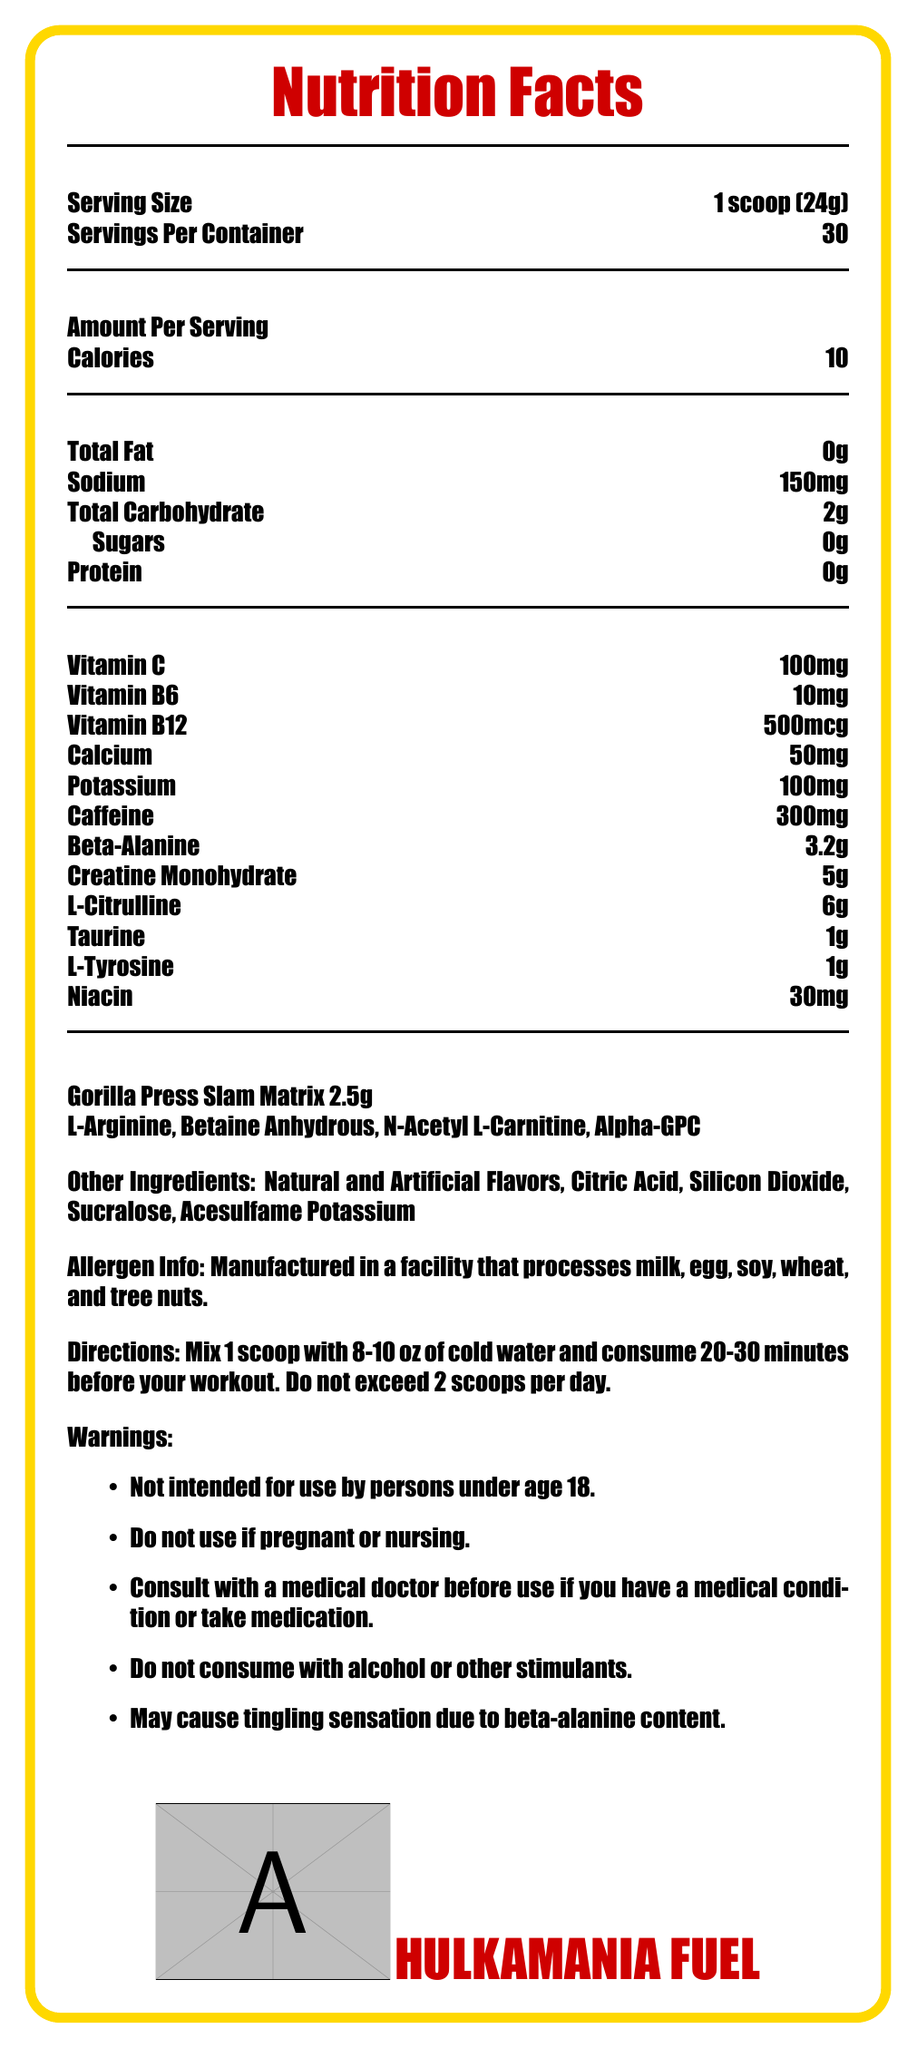What is the serving size of Hulkamania Fuel? The serving size is explicitly listed as 1 scoop (24g) in the document.
Answer: 1 scoop (24g) How many servings are there per container? The document states that there are 30 servings per container.
Answer: 30 How many calories are in one serving of Hulkamania Fuel? The document indicates that there are 10 calories per serving.
Answer: 10 How much caffeine is in each serving? The amount of caffeine per serving is specified as 300mg.
Answer: 300mg Name two vitamins found in Hulkamania Fuel and their amounts. Vitamin C and Vitamin B12 amounts are clearly listed in the document.
Answer: Vitamin C: 100mg, Vitamin B12: 500mcg What is the total weight of the proprietary blend "Gorilla Press Slam Matrix"? The document mentions that the total weight of the Gorilla Press Slam Matrix blend is 2.5g.
Answer: 2.5g Which of the following ingredients is not part of the "Gorilla Press Slam Matrix"? A. L-Arginine B. Betaine Anhydrous C. Alpha-GPC D. Silicon Dioxide Silicon Dioxide is listed as one of the other ingredients, not part of the proprietary blend.
Answer: D. Silicon Dioxide Which ingredient could cause a tingling sensation? A. L-Arginine B. Betaine Anhydrous C. Alpha-GPC D. Beta-Alanine The document provides a warning that the beta-alanine content might cause a tingling sensation.
Answer: D. Beta-Alanine True or False: Hulkamania Fuel contains sugar. The document lists the sugar content as 0g.
Answer: False What should you do before consuming Hulkamania Fuel if you have a medical condition? The warnings section advises consulting with a medical doctor if you have a medical condition.
Answer: Consult with a medical doctor Summarize the main idea of the document. The document describes the nutritional content and other vital information regarding Hulkamania Fuel, a pre-workout supplement meant for intense exercise routines. It highlights its critical ingredients, serving instructions, and safety precautions.
Answer: Hulkamania Fuel is a pre-workout energy drink providing various nutrients and compounds designed for intense training sessions, including vitamins, minerals, caffeine, amino acids, and a proprietary blend. The label provides serving size, nutritional content, ingredient information, usage directions, and warnings. What is the recommended water volume for mixing with one scoop of Hulkamania Fuel? The directions instruct users to mix 1 scoop with 8-10 oz of cold water.
Answer: 8-10 oz Can this product be used by someone who is pregnant? The warnings clearly state not to use the product if pregnant or nursing.
Answer: No Which training aid's amount is higher in each serving: Creatine Monohydrate or L-Citrulline? The document lists 6g of L-Citrulline and 5g of Creatine Monohydrate per serving.
Answer: L-Citrulline How many grams of protein are in each serving of Hulkamania Fuel? The document lists the protein content as 0g.
Answer: 0g Does Hulkamania Fuel contain any artificial ingredients? The product contains artificial flavors and sucralose as listed in the ingredient section.
Answer: Yes Where is this product manufactured? The document does not provide information about the manufacturing location.
Answer: Cannot be determined 